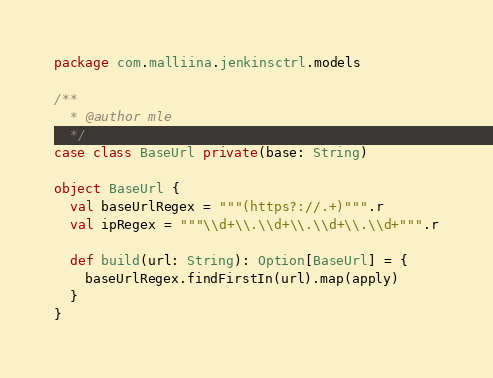Convert code to text. <code><loc_0><loc_0><loc_500><loc_500><_Scala_>package com.malliina.jenkinsctrl.models

/**
  * @author mle
  */
case class BaseUrl private(base: String)

object BaseUrl {
  val baseUrlRegex = """(https?://.+)""".r
  val ipRegex = """\\d+\\.\\d+\\.\\d+\\.\\d+""".r

  def build(url: String): Option[BaseUrl] = {
    baseUrlRegex.findFirstIn(url).map(apply)
  }
}
</code> 